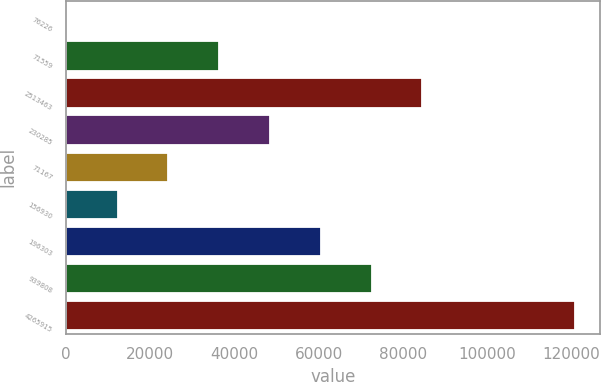Convert chart. <chart><loc_0><loc_0><loc_500><loc_500><bar_chart><fcel>76226<fcel>71559<fcel>2513463<fcel>230285<fcel>71167<fcel>156930<fcel>196303<fcel>939808<fcel>4265915<nl><fcel>158<fcel>36362<fcel>84634<fcel>48430<fcel>24294<fcel>12226<fcel>60498<fcel>72566<fcel>120838<nl></chart> 